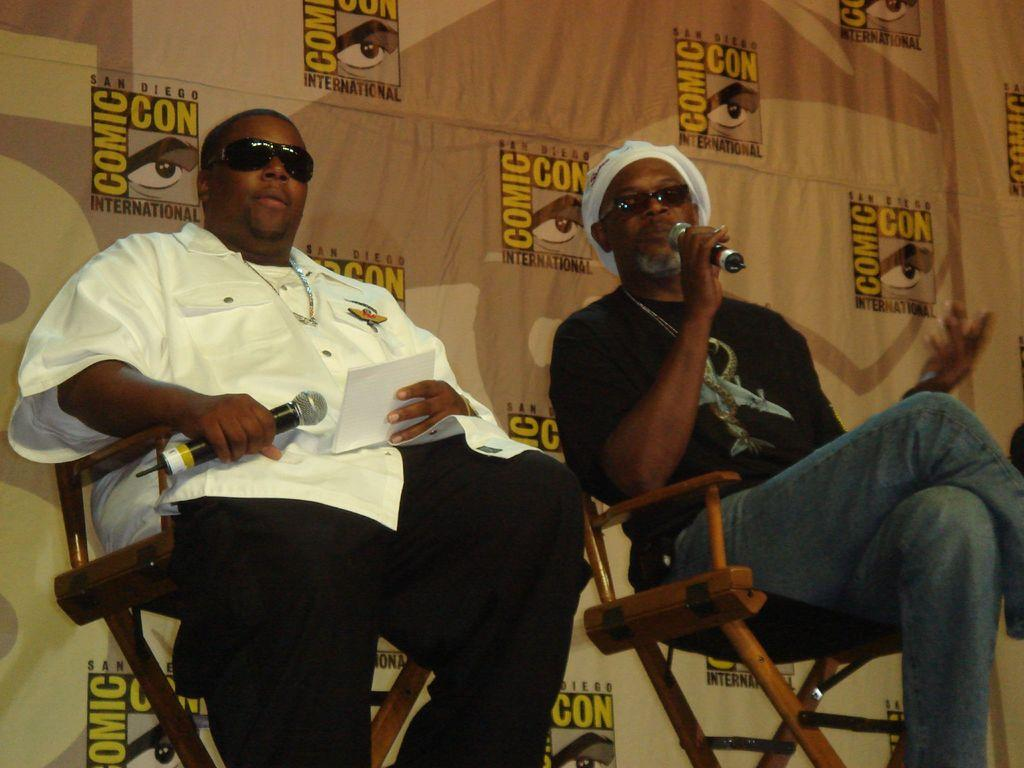How many people are in the image? There are two men in the image. What are the men doing in the image? The men are sitting on chairs and holding microphones. What are the men wearing on their faces? The men are wearing goggles. What can be seen in the background of the image? There is a hoarding in the background of the image. What type of cakes are the men eating in the image? There are no cakes present in the image; the men are holding microphones and wearing goggles while sitting on chairs. 